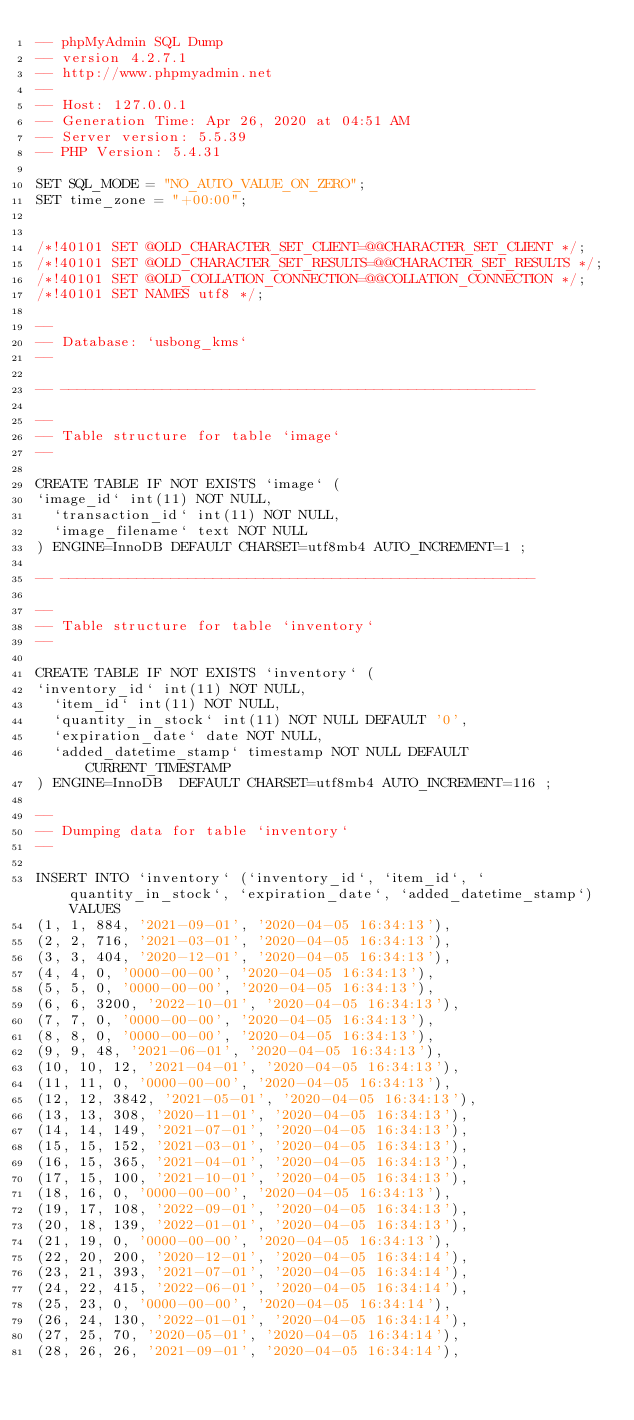Convert code to text. <code><loc_0><loc_0><loc_500><loc_500><_SQL_>-- phpMyAdmin SQL Dump
-- version 4.2.7.1
-- http://www.phpmyadmin.net
--
-- Host: 127.0.0.1
-- Generation Time: Apr 26, 2020 at 04:51 AM
-- Server version: 5.5.39
-- PHP Version: 5.4.31

SET SQL_MODE = "NO_AUTO_VALUE_ON_ZERO";
SET time_zone = "+00:00";


/*!40101 SET @OLD_CHARACTER_SET_CLIENT=@@CHARACTER_SET_CLIENT */;
/*!40101 SET @OLD_CHARACTER_SET_RESULTS=@@CHARACTER_SET_RESULTS */;
/*!40101 SET @OLD_COLLATION_CONNECTION=@@COLLATION_CONNECTION */;
/*!40101 SET NAMES utf8 */;

--
-- Database: `usbong_kms`
--

-- --------------------------------------------------------

--
-- Table structure for table `image`
--

CREATE TABLE IF NOT EXISTS `image` (
`image_id` int(11) NOT NULL,
  `transaction_id` int(11) NOT NULL,
  `image_filename` text NOT NULL
) ENGINE=InnoDB DEFAULT CHARSET=utf8mb4 AUTO_INCREMENT=1 ;

-- --------------------------------------------------------

--
-- Table structure for table `inventory`
--

CREATE TABLE IF NOT EXISTS `inventory` (
`inventory_id` int(11) NOT NULL,
  `item_id` int(11) NOT NULL,
  `quantity_in_stock` int(11) NOT NULL DEFAULT '0',
  `expiration_date` date NOT NULL,
  `added_datetime_stamp` timestamp NOT NULL DEFAULT CURRENT_TIMESTAMP
) ENGINE=InnoDB  DEFAULT CHARSET=utf8mb4 AUTO_INCREMENT=116 ;

--
-- Dumping data for table `inventory`
--

INSERT INTO `inventory` (`inventory_id`, `item_id`, `quantity_in_stock`, `expiration_date`, `added_datetime_stamp`) VALUES
(1, 1, 884, '2021-09-01', '2020-04-05 16:34:13'),
(2, 2, 716, '2021-03-01', '2020-04-05 16:34:13'),
(3, 3, 404, '2020-12-01', '2020-04-05 16:34:13'),
(4, 4, 0, '0000-00-00', '2020-04-05 16:34:13'),
(5, 5, 0, '0000-00-00', '2020-04-05 16:34:13'),
(6, 6, 3200, '2022-10-01', '2020-04-05 16:34:13'),
(7, 7, 0, '0000-00-00', '2020-04-05 16:34:13'),
(8, 8, 0, '0000-00-00', '2020-04-05 16:34:13'),
(9, 9, 48, '2021-06-01', '2020-04-05 16:34:13'),
(10, 10, 12, '2021-04-01', '2020-04-05 16:34:13'),
(11, 11, 0, '0000-00-00', '2020-04-05 16:34:13'),
(12, 12, 3842, '2021-05-01', '2020-04-05 16:34:13'),
(13, 13, 308, '2020-11-01', '2020-04-05 16:34:13'),
(14, 14, 149, '2021-07-01', '2020-04-05 16:34:13'),
(15, 15, 152, '2021-03-01', '2020-04-05 16:34:13'),
(16, 15, 365, '2021-04-01', '2020-04-05 16:34:13'),
(17, 15, 100, '2021-10-01', '2020-04-05 16:34:13'),
(18, 16, 0, '0000-00-00', '2020-04-05 16:34:13'),
(19, 17, 108, '2022-09-01', '2020-04-05 16:34:13'),
(20, 18, 139, '2022-01-01', '2020-04-05 16:34:13'),
(21, 19, 0, '0000-00-00', '2020-04-05 16:34:13'),
(22, 20, 200, '2020-12-01', '2020-04-05 16:34:14'),
(23, 21, 393, '2021-07-01', '2020-04-05 16:34:14'),
(24, 22, 415, '2022-06-01', '2020-04-05 16:34:14'),
(25, 23, 0, '0000-00-00', '2020-04-05 16:34:14'),
(26, 24, 130, '2022-01-01', '2020-04-05 16:34:14'),
(27, 25, 70, '2020-05-01', '2020-04-05 16:34:14'),
(28, 26, 26, '2021-09-01', '2020-04-05 16:34:14'),</code> 